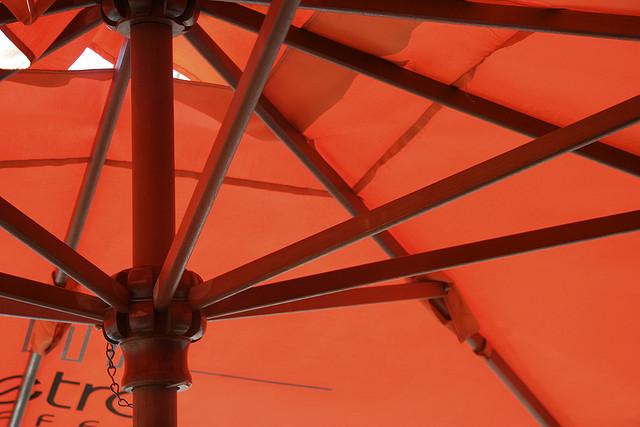How many metal rods are holding this umbrella?
Keep it brief. 8. What is the purpose of the umbrella?
Quick response, please. Shade. Is the umbrella ripped?
Answer briefly. No. Are there leaves in the umbrellas?
Quick response, please. No. What does the little chain do?
Write a very short answer. Open and close. Is there writing on the umbrella?
Keep it brief. Yes. 